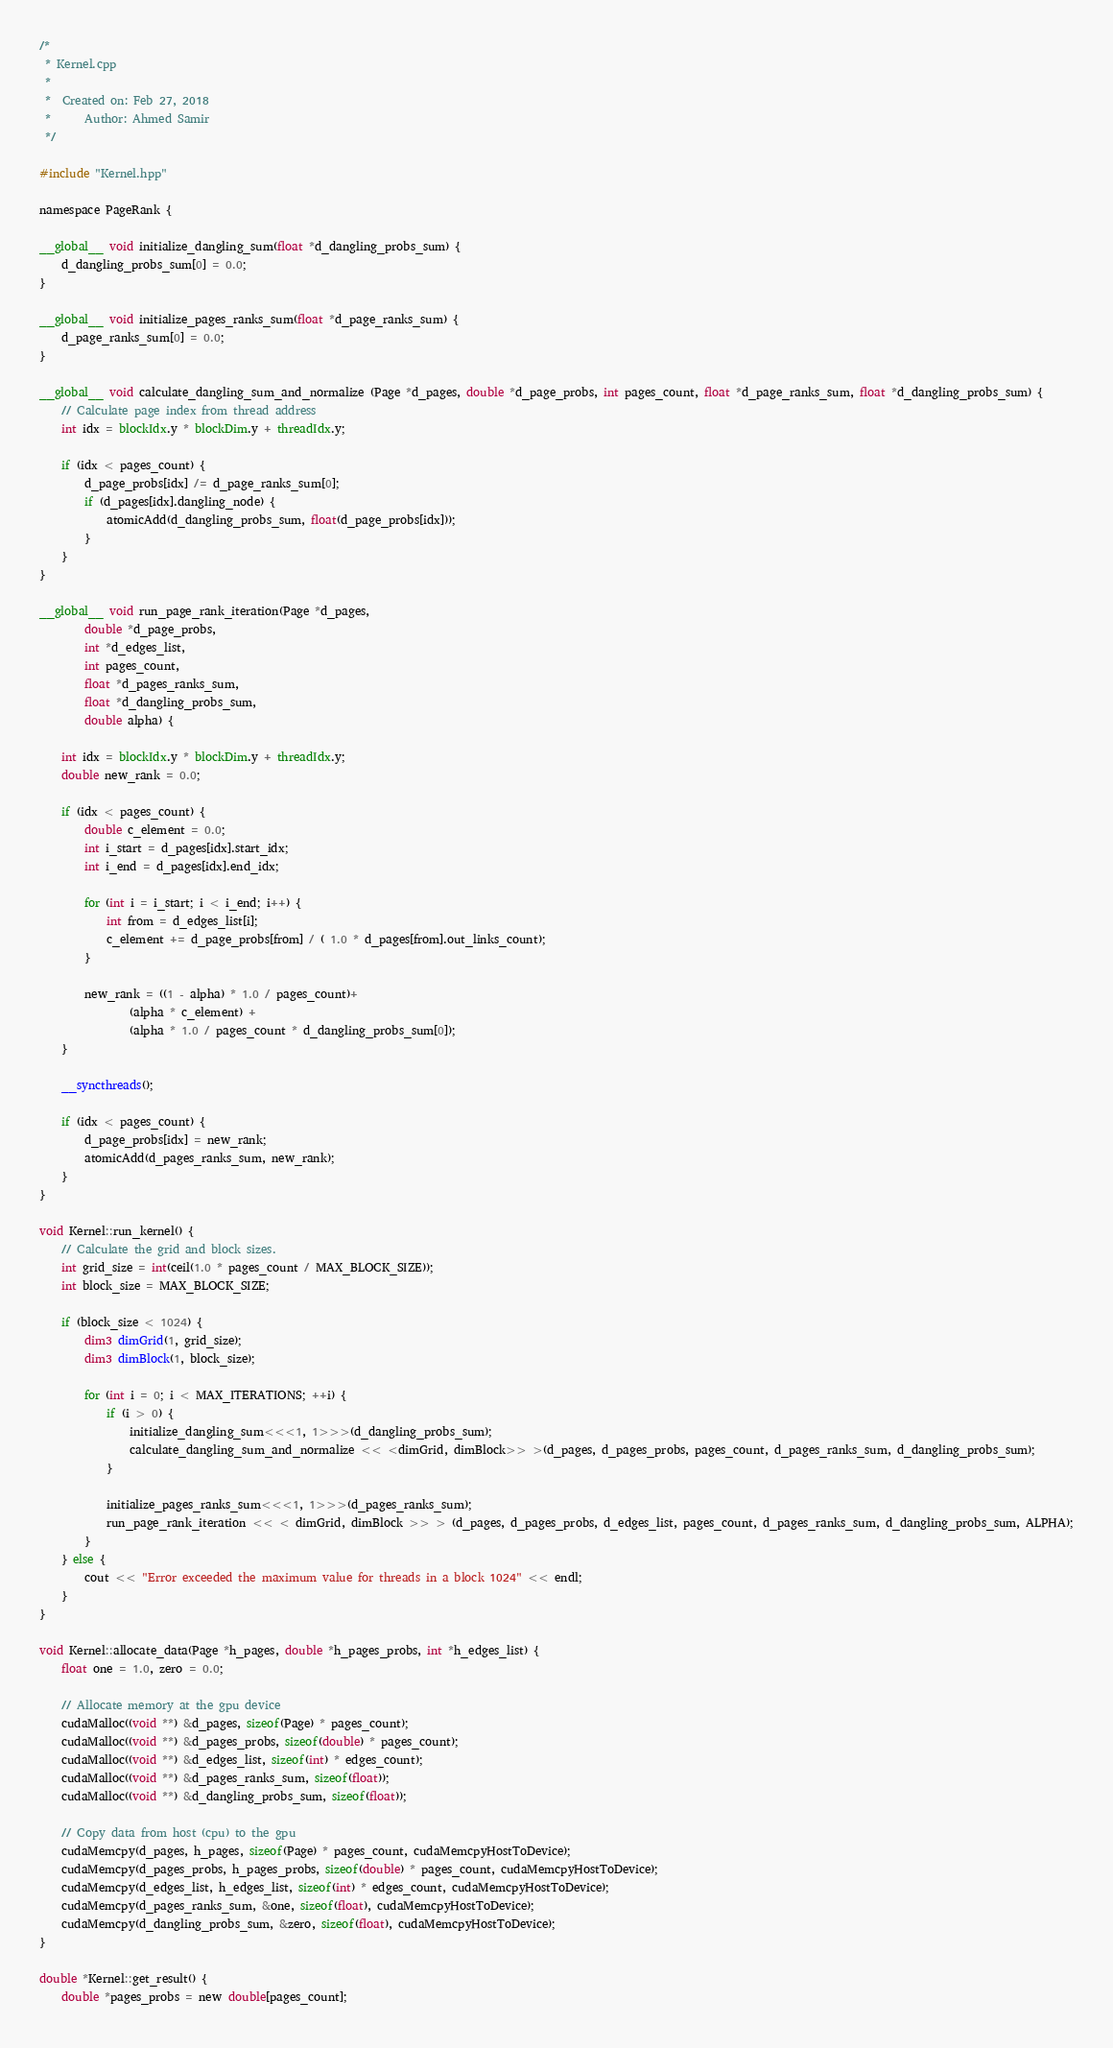<code> <loc_0><loc_0><loc_500><loc_500><_Cuda_>/*
 * Kernel.cpp
 *
 *  Created on: Feb 27, 2018
 *      Author: Ahmed Samir
 */

#include "Kernel.hpp"

namespace PageRank {

__global__ void initialize_dangling_sum(float *d_dangling_probs_sum) {
	d_dangling_probs_sum[0] = 0.0;
}

__global__ void initialize_pages_ranks_sum(float *d_page_ranks_sum) {
	d_page_ranks_sum[0] = 0.0;
}

__global__ void calculate_dangling_sum_and_normalize (Page *d_pages, double *d_page_probs, int pages_count, float *d_page_ranks_sum, float *d_dangling_probs_sum) {
	// Calculate page index from thread address
	int idx = blockIdx.y * blockDim.y + threadIdx.y;

	if (idx < pages_count) {
		d_page_probs[idx] /= d_page_ranks_sum[0];
		if (d_pages[idx].dangling_node) {
			atomicAdd(d_dangling_probs_sum, float(d_page_probs[idx]));
		}
	}
}

__global__ void run_page_rank_iteration(Page *d_pages,
		double *d_page_probs,
		int *d_edges_list,
		int pages_count,
		float *d_pages_ranks_sum,
		float *d_dangling_probs_sum,
		double alpha) {

	int idx = blockIdx.y * blockDim.y + threadIdx.y;
	double new_rank = 0.0;

	if (idx < pages_count) {
		double c_element = 0.0;
		int i_start = d_pages[idx].start_idx;
		int i_end = d_pages[idx].end_idx;

		for (int i = i_start; i < i_end; i++) {
			int from = d_edges_list[i];
			c_element += d_page_probs[from] / ( 1.0 * d_pages[from].out_links_count);
		}

		new_rank = ((1 - alpha) * 1.0 / pages_count)+
				(alpha * c_element) +
				(alpha * 1.0 / pages_count * d_dangling_probs_sum[0]);
	}

	__syncthreads();

	if (idx < pages_count) {
		d_page_probs[idx] = new_rank;
		atomicAdd(d_pages_ranks_sum, new_rank);
	}
}

void Kernel::run_kernel() {
	// Calculate the grid and block sizes.
	int grid_size = int(ceil(1.0 * pages_count / MAX_BLOCK_SIZE));
	int block_size = MAX_BLOCK_SIZE;

	if (block_size < 1024) {
		dim3 dimGrid(1, grid_size);
		dim3 dimBlock(1, block_size);

		for (int i = 0; i < MAX_ITERATIONS; ++i) {
			if (i > 0) {
				initialize_dangling_sum<<<1, 1>>>(d_dangling_probs_sum);
				calculate_dangling_sum_and_normalize << <dimGrid, dimBlock>> >(d_pages, d_pages_probs, pages_count, d_pages_ranks_sum, d_dangling_probs_sum);
			}

			initialize_pages_ranks_sum<<<1, 1>>>(d_pages_ranks_sum);
			run_page_rank_iteration << < dimGrid, dimBlock >> > (d_pages, d_pages_probs, d_edges_list, pages_count, d_pages_ranks_sum, d_dangling_probs_sum, ALPHA);
		}
	} else {
		cout << "Error exceeded the maximum value for threads in a block 1024" << endl;
	}
}

void Kernel::allocate_data(Page *h_pages, double *h_pages_probs, int *h_edges_list) {
	float one = 1.0, zero = 0.0;

	// Allocate memory at the gpu device
	cudaMalloc((void **) &d_pages, sizeof(Page) * pages_count);
	cudaMalloc((void **) &d_pages_probs, sizeof(double) * pages_count);
	cudaMalloc((void **) &d_edges_list, sizeof(int) * edges_count);
	cudaMalloc((void **) &d_pages_ranks_sum, sizeof(float));
	cudaMalloc((void **) &d_dangling_probs_sum, sizeof(float));

	// Copy data from host (cpu) to the gpu
	cudaMemcpy(d_pages, h_pages, sizeof(Page) * pages_count, cudaMemcpyHostToDevice);
	cudaMemcpy(d_pages_probs, h_pages_probs, sizeof(double) * pages_count, cudaMemcpyHostToDevice);
	cudaMemcpy(d_edges_list, h_edges_list, sizeof(int) * edges_count, cudaMemcpyHostToDevice);
	cudaMemcpy(d_pages_ranks_sum, &one, sizeof(float), cudaMemcpyHostToDevice);
	cudaMemcpy(d_dangling_probs_sum, &zero, sizeof(float), cudaMemcpyHostToDevice);
}

double *Kernel::get_result() {
	double *pages_probs = new double[pages_count];
</code> 